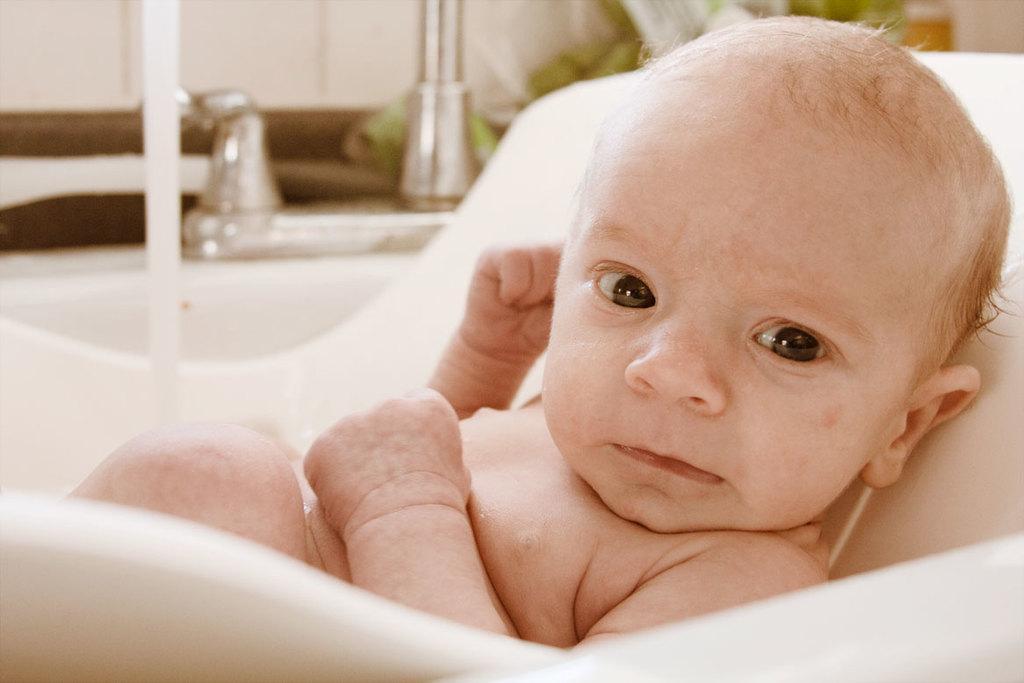Please provide a concise description of this image. In this image we can see a baby on a chair. On the backside we can see a pole and a wall. 